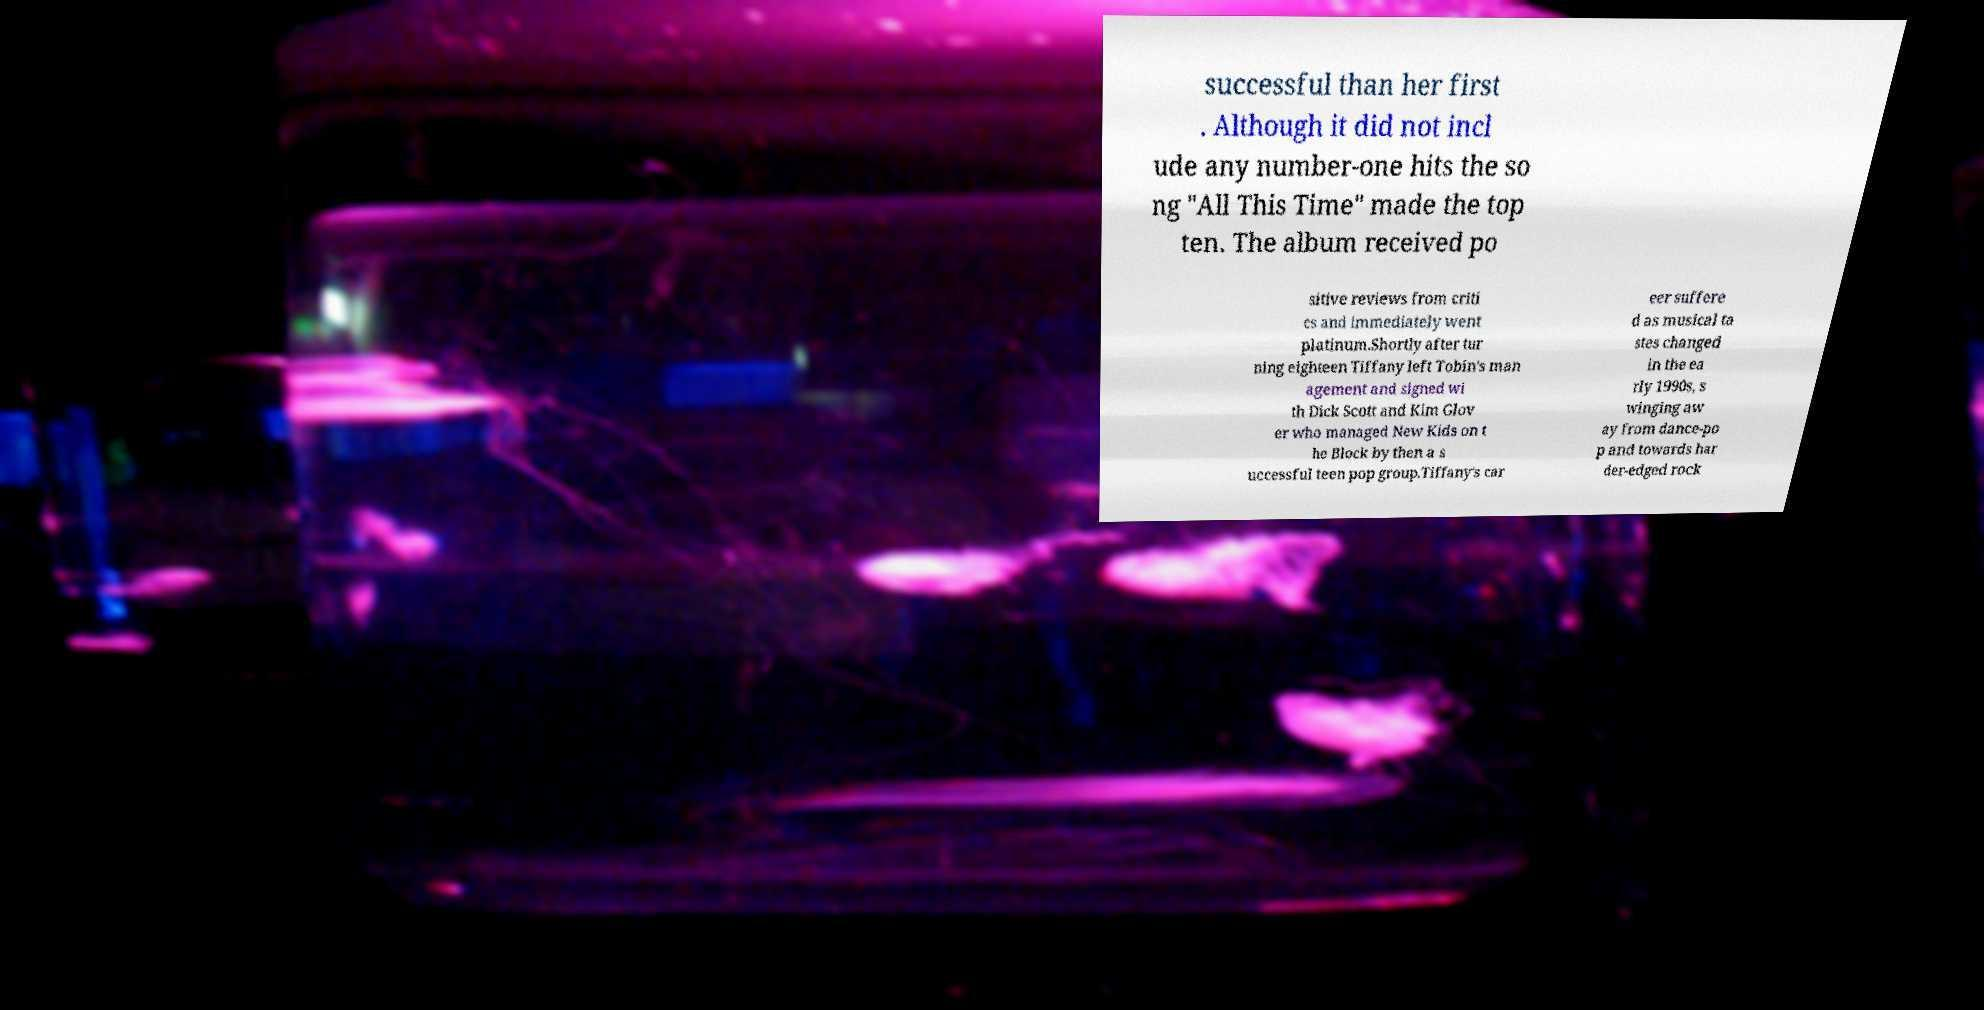Please identify and transcribe the text found in this image. successful than her first . Although it did not incl ude any number-one hits the so ng "All This Time" made the top ten. The album received po sitive reviews from criti cs and immediately went platinum.Shortly after tur ning eighteen Tiffany left Tobin's man agement and signed wi th Dick Scott and Kim Glov er who managed New Kids on t he Block by then a s uccessful teen pop group.Tiffany's car eer suffere d as musical ta stes changed in the ea rly 1990s, s winging aw ay from dance-po p and towards har der-edged rock 